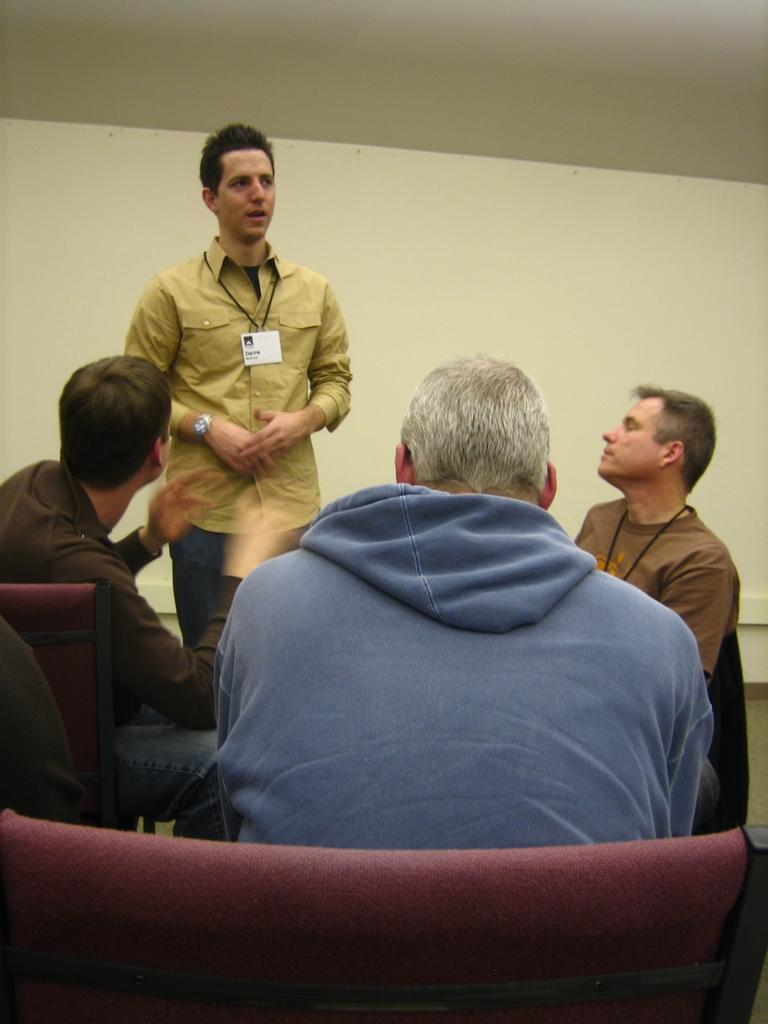How many people are present in the room? There are four people in the room. What are the positions of the people in the room? Three of them are sitting, and one person is standing and talking. What can be seen in the background of the room? There is a wall in the background. What type of hook is being used for writing in the image? There is no hook present in the image, and no one is writing. 